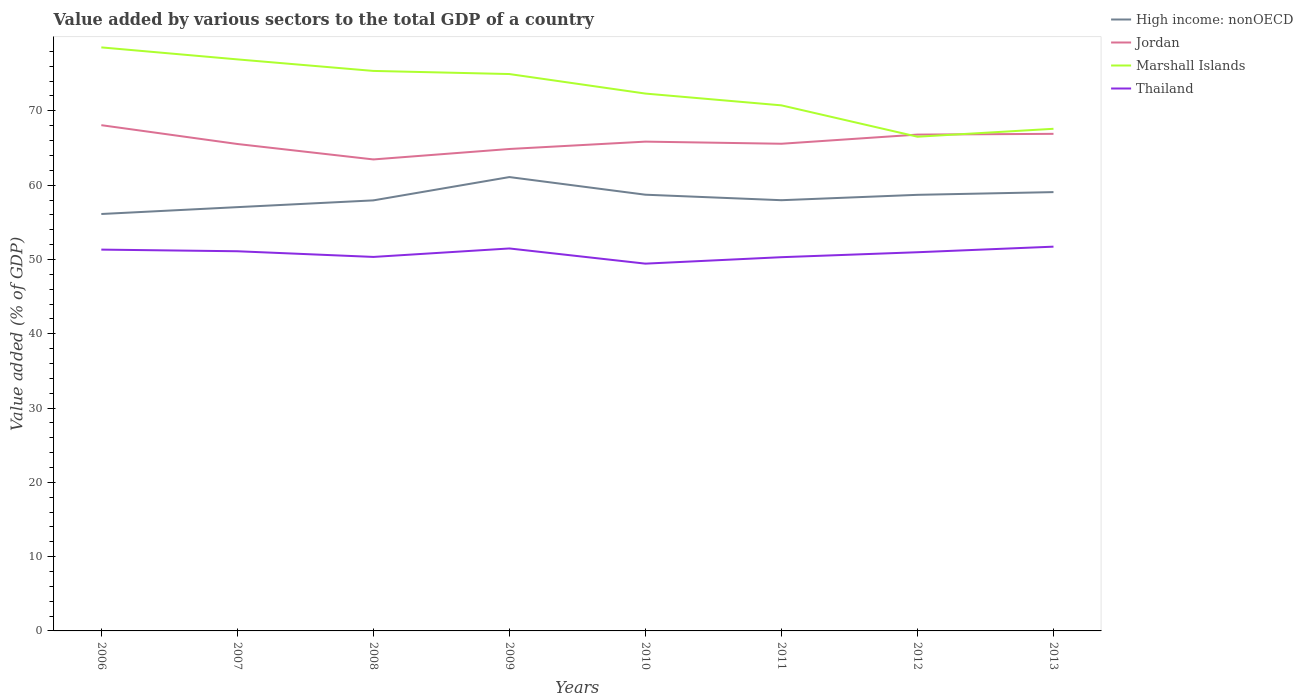Across all years, what is the maximum value added by various sectors to the total GDP in High income: nonOECD?
Ensure brevity in your answer.  56.12. In which year was the value added by various sectors to the total GDP in Thailand maximum?
Offer a terse response. 2010. What is the total value added by various sectors to the total GDP in High income: nonOECD in the graph?
Offer a very short reply. 0.74. What is the difference between the highest and the second highest value added by various sectors to the total GDP in High income: nonOECD?
Make the answer very short. 4.97. What is the difference between the highest and the lowest value added by various sectors to the total GDP in Jordan?
Your answer should be very brief. 3. Is the value added by various sectors to the total GDP in Thailand strictly greater than the value added by various sectors to the total GDP in Marshall Islands over the years?
Your answer should be compact. Yes. How many lines are there?
Your answer should be very brief. 4. How many years are there in the graph?
Provide a short and direct response. 8. What is the difference between two consecutive major ticks on the Y-axis?
Your answer should be compact. 10. Are the values on the major ticks of Y-axis written in scientific E-notation?
Keep it short and to the point. No. Does the graph contain grids?
Your response must be concise. No. Where does the legend appear in the graph?
Make the answer very short. Top right. What is the title of the graph?
Keep it short and to the point. Value added by various sectors to the total GDP of a country. What is the label or title of the Y-axis?
Your response must be concise. Value added (% of GDP). What is the Value added (% of GDP) in High income: nonOECD in 2006?
Your answer should be compact. 56.12. What is the Value added (% of GDP) in Jordan in 2006?
Your answer should be very brief. 68.07. What is the Value added (% of GDP) in Marshall Islands in 2006?
Give a very brief answer. 78.54. What is the Value added (% of GDP) of Thailand in 2006?
Give a very brief answer. 51.32. What is the Value added (% of GDP) of High income: nonOECD in 2007?
Offer a terse response. 57.04. What is the Value added (% of GDP) in Jordan in 2007?
Your answer should be compact. 65.54. What is the Value added (% of GDP) of Marshall Islands in 2007?
Your answer should be very brief. 76.93. What is the Value added (% of GDP) in Thailand in 2007?
Ensure brevity in your answer.  51.1. What is the Value added (% of GDP) of High income: nonOECD in 2008?
Your answer should be very brief. 57.95. What is the Value added (% of GDP) of Jordan in 2008?
Offer a terse response. 63.46. What is the Value added (% of GDP) in Marshall Islands in 2008?
Your response must be concise. 75.37. What is the Value added (% of GDP) in Thailand in 2008?
Your answer should be very brief. 50.34. What is the Value added (% of GDP) in High income: nonOECD in 2009?
Give a very brief answer. 61.09. What is the Value added (% of GDP) of Jordan in 2009?
Provide a short and direct response. 64.87. What is the Value added (% of GDP) of Marshall Islands in 2009?
Your answer should be compact. 74.95. What is the Value added (% of GDP) of Thailand in 2009?
Provide a succinct answer. 51.48. What is the Value added (% of GDP) in High income: nonOECD in 2010?
Make the answer very short. 58.71. What is the Value added (% of GDP) of Jordan in 2010?
Offer a very short reply. 65.86. What is the Value added (% of GDP) of Marshall Islands in 2010?
Your answer should be very brief. 72.33. What is the Value added (% of GDP) in Thailand in 2010?
Provide a succinct answer. 49.44. What is the Value added (% of GDP) in High income: nonOECD in 2011?
Keep it short and to the point. 57.98. What is the Value added (% of GDP) of Jordan in 2011?
Give a very brief answer. 65.57. What is the Value added (% of GDP) in Marshall Islands in 2011?
Provide a short and direct response. 70.74. What is the Value added (% of GDP) of Thailand in 2011?
Your response must be concise. 50.3. What is the Value added (% of GDP) of High income: nonOECD in 2012?
Provide a succinct answer. 58.7. What is the Value added (% of GDP) in Jordan in 2012?
Your answer should be compact. 66.81. What is the Value added (% of GDP) of Marshall Islands in 2012?
Make the answer very short. 66.52. What is the Value added (% of GDP) in Thailand in 2012?
Your answer should be compact. 50.97. What is the Value added (% of GDP) in High income: nonOECD in 2013?
Give a very brief answer. 59.06. What is the Value added (% of GDP) in Jordan in 2013?
Your answer should be very brief. 66.91. What is the Value added (% of GDP) of Marshall Islands in 2013?
Offer a terse response. 67.59. What is the Value added (% of GDP) of Thailand in 2013?
Your response must be concise. 51.72. Across all years, what is the maximum Value added (% of GDP) in High income: nonOECD?
Provide a succinct answer. 61.09. Across all years, what is the maximum Value added (% of GDP) of Jordan?
Provide a succinct answer. 68.07. Across all years, what is the maximum Value added (% of GDP) in Marshall Islands?
Give a very brief answer. 78.54. Across all years, what is the maximum Value added (% of GDP) of Thailand?
Your answer should be compact. 51.72. Across all years, what is the minimum Value added (% of GDP) of High income: nonOECD?
Your answer should be very brief. 56.12. Across all years, what is the minimum Value added (% of GDP) of Jordan?
Your answer should be very brief. 63.46. Across all years, what is the minimum Value added (% of GDP) in Marshall Islands?
Provide a succinct answer. 66.52. Across all years, what is the minimum Value added (% of GDP) of Thailand?
Keep it short and to the point. 49.44. What is the total Value added (% of GDP) in High income: nonOECD in the graph?
Your answer should be compact. 466.65. What is the total Value added (% of GDP) of Jordan in the graph?
Give a very brief answer. 527.09. What is the total Value added (% of GDP) in Marshall Islands in the graph?
Provide a succinct answer. 582.97. What is the total Value added (% of GDP) of Thailand in the graph?
Keep it short and to the point. 406.68. What is the difference between the Value added (% of GDP) in High income: nonOECD in 2006 and that in 2007?
Give a very brief answer. -0.92. What is the difference between the Value added (% of GDP) in Jordan in 2006 and that in 2007?
Provide a short and direct response. 2.53. What is the difference between the Value added (% of GDP) in Marshall Islands in 2006 and that in 2007?
Provide a short and direct response. 1.61. What is the difference between the Value added (% of GDP) in Thailand in 2006 and that in 2007?
Offer a terse response. 0.22. What is the difference between the Value added (% of GDP) in High income: nonOECD in 2006 and that in 2008?
Offer a very short reply. -1.83. What is the difference between the Value added (% of GDP) of Jordan in 2006 and that in 2008?
Your response must be concise. 4.61. What is the difference between the Value added (% of GDP) in Marshall Islands in 2006 and that in 2008?
Provide a short and direct response. 3.17. What is the difference between the Value added (% of GDP) of Thailand in 2006 and that in 2008?
Your answer should be compact. 0.98. What is the difference between the Value added (% of GDP) in High income: nonOECD in 2006 and that in 2009?
Your response must be concise. -4.97. What is the difference between the Value added (% of GDP) of Jordan in 2006 and that in 2009?
Provide a short and direct response. 3.21. What is the difference between the Value added (% of GDP) of Marshall Islands in 2006 and that in 2009?
Your response must be concise. 3.59. What is the difference between the Value added (% of GDP) of Thailand in 2006 and that in 2009?
Offer a terse response. -0.15. What is the difference between the Value added (% of GDP) in High income: nonOECD in 2006 and that in 2010?
Your response must be concise. -2.6. What is the difference between the Value added (% of GDP) of Jordan in 2006 and that in 2010?
Keep it short and to the point. 2.21. What is the difference between the Value added (% of GDP) of Marshall Islands in 2006 and that in 2010?
Ensure brevity in your answer.  6.22. What is the difference between the Value added (% of GDP) in Thailand in 2006 and that in 2010?
Provide a succinct answer. 1.89. What is the difference between the Value added (% of GDP) of High income: nonOECD in 2006 and that in 2011?
Your answer should be very brief. -1.86. What is the difference between the Value added (% of GDP) in Jordan in 2006 and that in 2011?
Offer a terse response. 2.5. What is the difference between the Value added (% of GDP) in Marshall Islands in 2006 and that in 2011?
Give a very brief answer. 7.8. What is the difference between the Value added (% of GDP) in Thailand in 2006 and that in 2011?
Provide a short and direct response. 1.02. What is the difference between the Value added (% of GDP) in High income: nonOECD in 2006 and that in 2012?
Offer a very short reply. -2.58. What is the difference between the Value added (% of GDP) of Jordan in 2006 and that in 2012?
Ensure brevity in your answer.  1.27. What is the difference between the Value added (% of GDP) in Marshall Islands in 2006 and that in 2012?
Offer a terse response. 12.02. What is the difference between the Value added (% of GDP) of Thailand in 2006 and that in 2012?
Ensure brevity in your answer.  0.35. What is the difference between the Value added (% of GDP) of High income: nonOECD in 2006 and that in 2013?
Provide a succinct answer. -2.95. What is the difference between the Value added (% of GDP) in Jordan in 2006 and that in 2013?
Make the answer very short. 1.17. What is the difference between the Value added (% of GDP) of Marshall Islands in 2006 and that in 2013?
Provide a short and direct response. 10.96. What is the difference between the Value added (% of GDP) in Thailand in 2006 and that in 2013?
Offer a terse response. -0.4. What is the difference between the Value added (% of GDP) in High income: nonOECD in 2007 and that in 2008?
Your answer should be compact. -0.91. What is the difference between the Value added (% of GDP) of Jordan in 2007 and that in 2008?
Ensure brevity in your answer.  2.08. What is the difference between the Value added (% of GDP) in Marshall Islands in 2007 and that in 2008?
Your response must be concise. 1.55. What is the difference between the Value added (% of GDP) of Thailand in 2007 and that in 2008?
Give a very brief answer. 0.76. What is the difference between the Value added (% of GDP) of High income: nonOECD in 2007 and that in 2009?
Keep it short and to the point. -4.05. What is the difference between the Value added (% of GDP) of Jordan in 2007 and that in 2009?
Your response must be concise. 0.67. What is the difference between the Value added (% of GDP) of Marshall Islands in 2007 and that in 2009?
Provide a short and direct response. 1.97. What is the difference between the Value added (% of GDP) in Thailand in 2007 and that in 2009?
Your answer should be very brief. -0.38. What is the difference between the Value added (% of GDP) of High income: nonOECD in 2007 and that in 2010?
Offer a very short reply. -1.67. What is the difference between the Value added (% of GDP) of Jordan in 2007 and that in 2010?
Give a very brief answer. -0.32. What is the difference between the Value added (% of GDP) of Marshall Islands in 2007 and that in 2010?
Your answer should be compact. 4.6. What is the difference between the Value added (% of GDP) of Thailand in 2007 and that in 2010?
Your answer should be compact. 1.67. What is the difference between the Value added (% of GDP) of High income: nonOECD in 2007 and that in 2011?
Give a very brief answer. -0.94. What is the difference between the Value added (% of GDP) of Jordan in 2007 and that in 2011?
Offer a very short reply. -0.03. What is the difference between the Value added (% of GDP) in Marshall Islands in 2007 and that in 2011?
Give a very brief answer. 6.19. What is the difference between the Value added (% of GDP) of Thailand in 2007 and that in 2011?
Ensure brevity in your answer.  0.8. What is the difference between the Value added (% of GDP) in High income: nonOECD in 2007 and that in 2012?
Provide a succinct answer. -1.66. What is the difference between the Value added (% of GDP) in Jordan in 2007 and that in 2012?
Offer a terse response. -1.26. What is the difference between the Value added (% of GDP) in Marshall Islands in 2007 and that in 2012?
Your answer should be compact. 10.41. What is the difference between the Value added (% of GDP) in Thailand in 2007 and that in 2012?
Your response must be concise. 0.13. What is the difference between the Value added (% of GDP) in High income: nonOECD in 2007 and that in 2013?
Your response must be concise. -2.02. What is the difference between the Value added (% of GDP) of Jordan in 2007 and that in 2013?
Provide a short and direct response. -1.37. What is the difference between the Value added (% of GDP) of Marshall Islands in 2007 and that in 2013?
Offer a terse response. 9.34. What is the difference between the Value added (% of GDP) of Thailand in 2007 and that in 2013?
Ensure brevity in your answer.  -0.62. What is the difference between the Value added (% of GDP) in High income: nonOECD in 2008 and that in 2009?
Provide a short and direct response. -3.14. What is the difference between the Value added (% of GDP) in Jordan in 2008 and that in 2009?
Ensure brevity in your answer.  -1.41. What is the difference between the Value added (% of GDP) of Marshall Islands in 2008 and that in 2009?
Offer a terse response. 0.42. What is the difference between the Value added (% of GDP) in Thailand in 2008 and that in 2009?
Your answer should be very brief. -1.14. What is the difference between the Value added (% of GDP) in High income: nonOECD in 2008 and that in 2010?
Provide a short and direct response. -0.76. What is the difference between the Value added (% of GDP) in Jordan in 2008 and that in 2010?
Offer a very short reply. -2.4. What is the difference between the Value added (% of GDP) of Marshall Islands in 2008 and that in 2010?
Your answer should be very brief. 3.05. What is the difference between the Value added (% of GDP) in Thailand in 2008 and that in 2010?
Keep it short and to the point. 0.9. What is the difference between the Value added (% of GDP) in High income: nonOECD in 2008 and that in 2011?
Keep it short and to the point. -0.02. What is the difference between the Value added (% of GDP) of Jordan in 2008 and that in 2011?
Provide a short and direct response. -2.11. What is the difference between the Value added (% of GDP) in Marshall Islands in 2008 and that in 2011?
Your answer should be compact. 4.63. What is the difference between the Value added (% of GDP) in Thailand in 2008 and that in 2011?
Provide a short and direct response. 0.03. What is the difference between the Value added (% of GDP) of High income: nonOECD in 2008 and that in 2012?
Give a very brief answer. -0.75. What is the difference between the Value added (% of GDP) of Jordan in 2008 and that in 2012?
Your response must be concise. -3.34. What is the difference between the Value added (% of GDP) of Marshall Islands in 2008 and that in 2012?
Your answer should be compact. 8.86. What is the difference between the Value added (% of GDP) in Thailand in 2008 and that in 2012?
Provide a succinct answer. -0.63. What is the difference between the Value added (% of GDP) in High income: nonOECD in 2008 and that in 2013?
Your response must be concise. -1.11. What is the difference between the Value added (% of GDP) of Jordan in 2008 and that in 2013?
Provide a short and direct response. -3.44. What is the difference between the Value added (% of GDP) in Marshall Islands in 2008 and that in 2013?
Your response must be concise. 7.79. What is the difference between the Value added (% of GDP) of Thailand in 2008 and that in 2013?
Your response must be concise. -1.38. What is the difference between the Value added (% of GDP) of High income: nonOECD in 2009 and that in 2010?
Your answer should be very brief. 2.37. What is the difference between the Value added (% of GDP) in Jordan in 2009 and that in 2010?
Offer a very short reply. -0.99. What is the difference between the Value added (% of GDP) of Marshall Islands in 2009 and that in 2010?
Give a very brief answer. 2.63. What is the difference between the Value added (% of GDP) of Thailand in 2009 and that in 2010?
Provide a short and direct response. 2.04. What is the difference between the Value added (% of GDP) in High income: nonOECD in 2009 and that in 2011?
Provide a succinct answer. 3.11. What is the difference between the Value added (% of GDP) in Jordan in 2009 and that in 2011?
Make the answer very short. -0.71. What is the difference between the Value added (% of GDP) in Marshall Islands in 2009 and that in 2011?
Offer a terse response. 4.21. What is the difference between the Value added (% of GDP) of Thailand in 2009 and that in 2011?
Provide a short and direct response. 1.17. What is the difference between the Value added (% of GDP) of High income: nonOECD in 2009 and that in 2012?
Keep it short and to the point. 2.39. What is the difference between the Value added (% of GDP) of Jordan in 2009 and that in 2012?
Your answer should be very brief. -1.94. What is the difference between the Value added (% of GDP) in Marshall Islands in 2009 and that in 2012?
Provide a succinct answer. 8.43. What is the difference between the Value added (% of GDP) of Thailand in 2009 and that in 2012?
Provide a short and direct response. 0.51. What is the difference between the Value added (% of GDP) of High income: nonOECD in 2009 and that in 2013?
Give a very brief answer. 2.02. What is the difference between the Value added (% of GDP) in Jordan in 2009 and that in 2013?
Make the answer very short. -2.04. What is the difference between the Value added (% of GDP) of Marshall Islands in 2009 and that in 2013?
Ensure brevity in your answer.  7.37. What is the difference between the Value added (% of GDP) of Thailand in 2009 and that in 2013?
Your answer should be very brief. -0.24. What is the difference between the Value added (% of GDP) of High income: nonOECD in 2010 and that in 2011?
Your answer should be very brief. 0.74. What is the difference between the Value added (% of GDP) of Jordan in 2010 and that in 2011?
Offer a terse response. 0.29. What is the difference between the Value added (% of GDP) of Marshall Islands in 2010 and that in 2011?
Your answer should be compact. 1.59. What is the difference between the Value added (% of GDP) of Thailand in 2010 and that in 2011?
Make the answer very short. -0.87. What is the difference between the Value added (% of GDP) of High income: nonOECD in 2010 and that in 2012?
Your answer should be compact. 0.02. What is the difference between the Value added (% of GDP) in Jordan in 2010 and that in 2012?
Give a very brief answer. -0.95. What is the difference between the Value added (% of GDP) in Marshall Islands in 2010 and that in 2012?
Offer a terse response. 5.81. What is the difference between the Value added (% of GDP) of Thailand in 2010 and that in 2012?
Your answer should be compact. -1.53. What is the difference between the Value added (% of GDP) of High income: nonOECD in 2010 and that in 2013?
Offer a terse response. -0.35. What is the difference between the Value added (% of GDP) of Jordan in 2010 and that in 2013?
Offer a very short reply. -1.05. What is the difference between the Value added (% of GDP) in Marshall Islands in 2010 and that in 2013?
Keep it short and to the point. 4.74. What is the difference between the Value added (% of GDP) in Thailand in 2010 and that in 2013?
Give a very brief answer. -2.29. What is the difference between the Value added (% of GDP) of High income: nonOECD in 2011 and that in 2012?
Make the answer very short. -0.72. What is the difference between the Value added (% of GDP) of Jordan in 2011 and that in 2012?
Give a very brief answer. -1.23. What is the difference between the Value added (% of GDP) in Marshall Islands in 2011 and that in 2012?
Offer a terse response. 4.22. What is the difference between the Value added (% of GDP) in Thailand in 2011 and that in 2012?
Offer a terse response. -0.67. What is the difference between the Value added (% of GDP) of High income: nonOECD in 2011 and that in 2013?
Your answer should be compact. -1.09. What is the difference between the Value added (% of GDP) of Jordan in 2011 and that in 2013?
Provide a short and direct response. -1.33. What is the difference between the Value added (% of GDP) of Marshall Islands in 2011 and that in 2013?
Your response must be concise. 3.15. What is the difference between the Value added (% of GDP) of Thailand in 2011 and that in 2013?
Offer a terse response. -1.42. What is the difference between the Value added (% of GDP) of High income: nonOECD in 2012 and that in 2013?
Offer a very short reply. -0.37. What is the difference between the Value added (% of GDP) in Jordan in 2012 and that in 2013?
Make the answer very short. -0.1. What is the difference between the Value added (% of GDP) of Marshall Islands in 2012 and that in 2013?
Provide a succinct answer. -1.07. What is the difference between the Value added (% of GDP) in Thailand in 2012 and that in 2013?
Offer a terse response. -0.75. What is the difference between the Value added (% of GDP) of High income: nonOECD in 2006 and the Value added (% of GDP) of Jordan in 2007?
Your response must be concise. -9.42. What is the difference between the Value added (% of GDP) of High income: nonOECD in 2006 and the Value added (% of GDP) of Marshall Islands in 2007?
Make the answer very short. -20.81. What is the difference between the Value added (% of GDP) in High income: nonOECD in 2006 and the Value added (% of GDP) in Thailand in 2007?
Your response must be concise. 5.01. What is the difference between the Value added (% of GDP) of Jordan in 2006 and the Value added (% of GDP) of Marshall Islands in 2007?
Give a very brief answer. -8.85. What is the difference between the Value added (% of GDP) in Jordan in 2006 and the Value added (% of GDP) in Thailand in 2007?
Offer a very short reply. 16.97. What is the difference between the Value added (% of GDP) of Marshall Islands in 2006 and the Value added (% of GDP) of Thailand in 2007?
Make the answer very short. 27.44. What is the difference between the Value added (% of GDP) in High income: nonOECD in 2006 and the Value added (% of GDP) in Jordan in 2008?
Keep it short and to the point. -7.34. What is the difference between the Value added (% of GDP) in High income: nonOECD in 2006 and the Value added (% of GDP) in Marshall Islands in 2008?
Offer a terse response. -19.26. What is the difference between the Value added (% of GDP) of High income: nonOECD in 2006 and the Value added (% of GDP) of Thailand in 2008?
Give a very brief answer. 5.78. What is the difference between the Value added (% of GDP) in Jordan in 2006 and the Value added (% of GDP) in Marshall Islands in 2008?
Offer a terse response. -7.3. What is the difference between the Value added (% of GDP) in Jordan in 2006 and the Value added (% of GDP) in Thailand in 2008?
Your answer should be compact. 17.73. What is the difference between the Value added (% of GDP) in Marshall Islands in 2006 and the Value added (% of GDP) in Thailand in 2008?
Give a very brief answer. 28.2. What is the difference between the Value added (% of GDP) of High income: nonOECD in 2006 and the Value added (% of GDP) of Jordan in 2009?
Ensure brevity in your answer.  -8.75. What is the difference between the Value added (% of GDP) of High income: nonOECD in 2006 and the Value added (% of GDP) of Marshall Islands in 2009?
Your answer should be very brief. -18.84. What is the difference between the Value added (% of GDP) in High income: nonOECD in 2006 and the Value added (% of GDP) in Thailand in 2009?
Provide a short and direct response. 4.64. What is the difference between the Value added (% of GDP) in Jordan in 2006 and the Value added (% of GDP) in Marshall Islands in 2009?
Your answer should be compact. -6.88. What is the difference between the Value added (% of GDP) of Jordan in 2006 and the Value added (% of GDP) of Thailand in 2009?
Provide a short and direct response. 16.59. What is the difference between the Value added (% of GDP) of Marshall Islands in 2006 and the Value added (% of GDP) of Thailand in 2009?
Ensure brevity in your answer.  27.06. What is the difference between the Value added (% of GDP) in High income: nonOECD in 2006 and the Value added (% of GDP) in Jordan in 2010?
Your response must be concise. -9.74. What is the difference between the Value added (% of GDP) in High income: nonOECD in 2006 and the Value added (% of GDP) in Marshall Islands in 2010?
Your response must be concise. -16.21. What is the difference between the Value added (% of GDP) in High income: nonOECD in 2006 and the Value added (% of GDP) in Thailand in 2010?
Provide a short and direct response. 6.68. What is the difference between the Value added (% of GDP) in Jordan in 2006 and the Value added (% of GDP) in Marshall Islands in 2010?
Keep it short and to the point. -4.25. What is the difference between the Value added (% of GDP) in Jordan in 2006 and the Value added (% of GDP) in Thailand in 2010?
Ensure brevity in your answer.  18.64. What is the difference between the Value added (% of GDP) in Marshall Islands in 2006 and the Value added (% of GDP) in Thailand in 2010?
Make the answer very short. 29.11. What is the difference between the Value added (% of GDP) in High income: nonOECD in 2006 and the Value added (% of GDP) in Jordan in 2011?
Provide a succinct answer. -9.46. What is the difference between the Value added (% of GDP) in High income: nonOECD in 2006 and the Value added (% of GDP) in Marshall Islands in 2011?
Give a very brief answer. -14.62. What is the difference between the Value added (% of GDP) in High income: nonOECD in 2006 and the Value added (% of GDP) in Thailand in 2011?
Your answer should be compact. 5.81. What is the difference between the Value added (% of GDP) of Jordan in 2006 and the Value added (% of GDP) of Marshall Islands in 2011?
Make the answer very short. -2.67. What is the difference between the Value added (% of GDP) of Jordan in 2006 and the Value added (% of GDP) of Thailand in 2011?
Keep it short and to the point. 17.77. What is the difference between the Value added (% of GDP) in Marshall Islands in 2006 and the Value added (% of GDP) in Thailand in 2011?
Your answer should be compact. 28.24. What is the difference between the Value added (% of GDP) in High income: nonOECD in 2006 and the Value added (% of GDP) in Jordan in 2012?
Your response must be concise. -10.69. What is the difference between the Value added (% of GDP) in High income: nonOECD in 2006 and the Value added (% of GDP) in Marshall Islands in 2012?
Provide a short and direct response. -10.4. What is the difference between the Value added (% of GDP) in High income: nonOECD in 2006 and the Value added (% of GDP) in Thailand in 2012?
Ensure brevity in your answer.  5.15. What is the difference between the Value added (% of GDP) of Jordan in 2006 and the Value added (% of GDP) of Marshall Islands in 2012?
Keep it short and to the point. 1.55. What is the difference between the Value added (% of GDP) in Jordan in 2006 and the Value added (% of GDP) in Thailand in 2012?
Offer a terse response. 17.1. What is the difference between the Value added (% of GDP) in Marshall Islands in 2006 and the Value added (% of GDP) in Thailand in 2012?
Keep it short and to the point. 27.57. What is the difference between the Value added (% of GDP) in High income: nonOECD in 2006 and the Value added (% of GDP) in Jordan in 2013?
Offer a very short reply. -10.79. What is the difference between the Value added (% of GDP) in High income: nonOECD in 2006 and the Value added (% of GDP) in Marshall Islands in 2013?
Offer a terse response. -11.47. What is the difference between the Value added (% of GDP) of High income: nonOECD in 2006 and the Value added (% of GDP) of Thailand in 2013?
Keep it short and to the point. 4.4. What is the difference between the Value added (% of GDP) in Jordan in 2006 and the Value added (% of GDP) in Marshall Islands in 2013?
Make the answer very short. 0.49. What is the difference between the Value added (% of GDP) of Jordan in 2006 and the Value added (% of GDP) of Thailand in 2013?
Provide a short and direct response. 16.35. What is the difference between the Value added (% of GDP) of Marshall Islands in 2006 and the Value added (% of GDP) of Thailand in 2013?
Your answer should be very brief. 26.82. What is the difference between the Value added (% of GDP) of High income: nonOECD in 2007 and the Value added (% of GDP) of Jordan in 2008?
Provide a short and direct response. -6.42. What is the difference between the Value added (% of GDP) in High income: nonOECD in 2007 and the Value added (% of GDP) in Marshall Islands in 2008?
Offer a very short reply. -18.33. What is the difference between the Value added (% of GDP) of High income: nonOECD in 2007 and the Value added (% of GDP) of Thailand in 2008?
Your response must be concise. 6.7. What is the difference between the Value added (% of GDP) of Jordan in 2007 and the Value added (% of GDP) of Marshall Islands in 2008?
Your answer should be compact. -9.83. What is the difference between the Value added (% of GDP) of Jordan in 2007 and the Value added (% of GDP) of Thailand in 2008?
Your answer should be very brief. 15.2. What is the difference between the Value added (% of GDP) in Marshall Islands in 2007 and the Value added (% of GDP) in Thailand in 2008?
Provide a succinct answer. 26.59. What is the difference between the Value added (% of GDP) in High income: nonOECD in 2007 and the Value added (% of GDP) in Jordan in 2009?
Make the answer very short. -7.83. What is the difference between the Value added (% of GDP) in High income: nonOECD in 2007 and the Value added (% of GDP) in Marshall Islands in 2009?
Keep it short and to the point. -17.91. What is the difference between the Value added (% of GDP) of High income: nonOECD in 2007 and the Value added (% of GDP) of Thailand in 2009?
Your response must be concise. 5.56. What is the difference between the Value added (% of GDP) of Jordan in 2007 and the Value added (% of GDP) of Marshall Islands in 2009?
Keep it short and to the point. -9.41. What is the difference between the Value added (% of GDP) of Jordan in 2007 and the Value added (% of GDP) of Thailand in 2009?
Offer a terse response. 14.06. What is the difference between the Value added (% of GDP) of Marshall Islands in 2007 and the Value added (% of GDP) of Thailand in 2009?
Ensure brevity in your answer.  25.45. What is the difference between the Value added (% of GDP) of High income: nonOECD in 2007 and the Value added (% of GDP) of Jordan in 2010?
Ensure brevity in your answer.  -8.82. What is the difference between the Value added (% of GDP) in High income: nonOECD in 2007 and the Value added (% of GDP) in Marshall Islands in 2010?
Your response must be concise. -15.29. What is the difference between the Value added (% of GDP) of High income: nonOECD in 2007 and the Value added (% of GDP) of Thailand in 2010?
Provide a short and direct response. 7.6. What is the difference between the Value added (% of GDP) in Jordan in 2007 and the Value added (% of GDP) in Marshall Islands in 2010?
Your response must be concise. -6.79. What is the difference between the Value added (% of GDP) of Jordan in 2007 and the Value added (% of GDP) of Thailand in 2010?
Offer a very short reply. 16.11. What is the difference between the Value added (% of GDP) of Marshall Islands in 2007 and the Value added (% of GDP) of Thailand in 2010?
Your answer should be compact. 27.49. What is the difference between the Value added (% of GDP) of High income: nonOECD in 2007 and the Value added (% of GDP) of Jordan in 2011?
Your response must be concise. -8.53. What is the difference between the Value added (% of GDP) of High income: nonOECD in 2007 and the Value added (% of GDP) of Marshall Islands in 2011?
Offer a very short reply. -13.7. What is the difference between the Value added (% of GDP) of High income: nonOECD in 2007 and the Value added (% of GDP) of Thailand in 2011?
Your response must be concise. 6.74. What is the difference between the Value added (% of GDP) of Jordan in 2007 and the Value added (% of GDP) of Marshall Islands in 2011?
Your answer should be compact. -5.2. What is the difference between the Value added (% of GDP) of Jordan in 2007 and the Value added (% of GDP) of Thailand in 2011?
Your answer should be very brief. 15.24. What is the difference between the Value added (% of GDP) of Marshall Islands in 2007 and the Value added (% of GDP) of Thailand in 2011?
Offer a very short reply. 26.62. What is the difference between the Value added (% of GDP) of High income: nonOECD in 2007 and the Value added (% of GDP) of Jordan in 2012?
Provide a succinct answer. -9.77. What is the difference between the Value added (% of GDP) in High income: nonOECD in 2007 and the Value added (% of GDP) in Marshall Islands in 2012?
Provide a succinct answer. -9.48. What is the difference between the Value added (% of GDP) in High income: nonOECD in 2007 and the Value added (% of GDP) in Thailand in 2012?
Your answer should be compact. 6.07. What is the difference between the Value added (% of GDP) in Jordan in 2007 and the Value added (% of GDP) in Marshall Islands in 2012?
Provide a succinct answer. -0.98. What is the difference between the Value added (% of GDP) of Jordan in 2007 and the Value added (% of GDP) of Thailand in 2012?
Provide a short and direct response. 14.57. What is the difference between the Value added (% of GDP) of Marshall Islands in 2007 and the Value added (% of GDP) of Thailand in 2012?
Provide a succinct answer. 25.96. What is the difference between the Value added (% of GDP) of High income: nonOECD in 2007 and the Value added (% of GDP) of Jordan in 2013?
Provide a succinct answer. -9.87. What is the difference between the Value added (% of GDP) of High income: nonOECD in 2007 and the Value added (% of GDP) of Marshall Islands in 2013?
Give a very brief answer. -10.55. What is the difference between the Value added (% of GDP) in High income: nonOECD in 2007 and the Value added (% of GDP) in Thailand in 2013?
Your answer should be compact. 5.32. What is the difference between the Value added (% of GDP) in Jordan in 2007 and the Value added (% of GDP) in Marshall Islands in 2013?
Make the answer very short. -2.05. What is the difference between the Value added (% of GDP) of Jordan in 2007 and the Value added (% of GDP) of Thailand in 2013?
Keep it short and to the point. 13.82. What is the difference between the Value added (% of GDP) in Marshall Islands in 2007 and the Value added (% of GDP) in Thailand in 2013?
Offer a very short reply. 25.21. What is the difference between the Value added (% of GDP) of High income: nonOECD in 2008 and the Value added (% of GDP) of Jordan in 2009?
Provide a short and direct response. -6.92. What is the difference between the Value added (% of GDP) of High income: nonOECD in 2008 and the Value added (% of GDP) of Marshall Islands in 2009?
Keep it short and to the point. -17. What is the difference between the Value added (% of GDP) of High income: nonOECD in 2008 and the Value added (% of GDP) of Thailand in 2009?
Your answer should be very brief. 6.47. What is the difference between the Value added (% of GDP) in Jordan in 2008 and the Value added (% of GDP) in Marshall Islands in 2009?
Your answer should be very brief. -11.49. What is the difference between the Value added (% of GDP) of Jordan in 2008 and the Value added (% of GDP) of Thailand in 2009?
Keep it short and to the point. 11.98. What is the difference between the Value added (% of GDP) in Marshall Islands in 2008 and the Value added (% of GDP) in Thailand in 2009?
Keep it short and to the point. 23.9. What is the difference between the Value added (% of GDP) in High income: nonOECD in 2008 and the Value added (% of GDP) in Jordan in 2010?
Give a very brief answer. -7.91. What is the difference between the Value added (% of GDP) of High income: nonOECD in 2008 and the Value added (% of GDP) of Marshall Islands in 2010?
Your answer should be very brief. -14.38. What is the difference between the Value added (% of GDP) in High income: nonOECD in 2008 and the Value added (% of GDP) in Thailand in 2010?
Your answer should be compact. 8.52. What is the difference between the Value added (% of GDP) in Jordan in 2008 and the Value added (% of GDP) in Marshall Islands in 2010?
Give a very brief answer. -8.87. What is the difference between the Value added (% of GDP) of Jordan in 2008 and the Value added (% of GDP) of Thailand in 2010?
Ensure brevity in your answer.  14.03. What is the difference between the Value added (% of GDP) of Marshall Islands in 2008 and the Value added (% of GDP) of Thailand in 2010?
Offer a terse response. 25.94. What is the difference between the Value added (% of GDP) of High income: nonOECD in 2008 and the Value added (% of GDP) of Jordan in 2011?
Offer a terse response. -7.62. What is the difference between the Value added (% of GDP) in High income: nonOECD in 2008 and the Value added (% of GDP) in Marshall Islands in 2011?
Provide a short and direct response. -12.79. What is the difference between the Value added (% of GDP) of High income: nonOECD in 2008 and the Value added (% of GDP) of Thailand in 2011?
Your answer should be compact. 7.65. What is the difference between the Value added (% of GDP) in Jordan in 2008 and the Value added (% of GDP) in Marshall Islands in 2011?
Your answer should be very brief. -7.28. What is the difference between the Value added (% of GDP) in Jordan in 2008 and the Value added (% of GDP) in Thailand in 2011?
Give a very brief answer. 13.16. What is the difference between the Value added (% of GDP) in Marshall Islands in 2008 and the Value added (% of GDP) in Thailand in 2011?
Make the answer very short. 25.07. What is the difference between the Value added (% of GDP) in High income: nonOECD in 2008 and the Value added (% of GDP) in Jordan in 2012?
Give a very brief answer. -8.85. What is the difference between the Value added (% of GDP) in High income: nonOECD in 2008 and the Value added (% of GDP) in Marshall Islands in 2012?
Provide a succinct answer. -8.57. What is the difference between the Value added (% of GDP) of High income: nonOECD in 2008 and the Value added (% of GDP) of Thailand in 2012?
Keep it short and to the point. 6.98. What is the difference between the Value added (% of GDP) of Jordan in 2008 and the Value added (% of GDP) of Marshall Islands in 2012?
Offer a terse response. -3.06. What is the difference between the Value added (% of GDP) of Jordan in 2008 and the Value added (% of GDP) of Thailand in 2012?
Your response must be concise. 12.49. What is the difference between the Value added (% of GDP) of Marshall Islands in 2008 and the Value added (% of GDP) of Thailand in 2012?
Ensure brevity in your answer.  24.4. What is the difference between the Value added (% of GDP) in High income: nonOECD in 2008 and the Value added (% of GDP) in Jordan in 2013?
Your answer should be very brief. -8.96. What is the difference between the Value added (% of GDP) in High income: nonOECD in 2008 and the Value added (% of GDP) in Marshall Islands in 2013?
Offer a very short reply. -9.64. What is the difference between the Value added (% of GDP) in High income: nonOECD in 2008 and the Value added (% of GDP) in Thailand in 2013?
Keep it short and to the point. 6.23. What is the difference between the Value added (% of GDP) in Jordan in 2008 and the Value added (% of GDP) in Marshall Islands in 2013?
Your answer should be compact. -4.12. What is the difference between the Value added (% of GDP) of Jordan in 2008 and the Value added (% of GDP) of Thailand in 2013?
Provide a succinct answer. 11.74. What is the difference between the Value added (% of GDP) of Marshall Islands in 2008 and the Value added (% of GDP) of Thailand in 2013?
Make the answer very short. 23.65. What is the difference between the Value added (% of GDP) of High income: nonOECD in 2009 and the Value added (% of GDP) of Jordan in 2010?
Give a very brief answer. -4.77. What is the difference between the Value added (% of GDP) of High income: nonOECD in 2009 and the Value added (% of GDP) of Marshall Islands in 2010?
Make the answer very short. -11.24. What is the difference between the Value added (% of GDP) of High income: nonOECD in 2009 and the Value added (% of GDP) of Thailand in 2010?
Your answer should be compact. 11.65. What is the difference between the Value added (% of GDP) in Jordan in 2009 and the Value added (% of GDP) in Marshall Islands in 2010?
Keep it short and to the point. -7.46. What is the difference between the Value added (% of GDP) of Jordan in 2009 and the Value added (% of GDP) of Thailand in 2010?
Ensure brevity in your answer.  15.43. What is the difference between the Value added (% of GDP) in Marshall Islands in 2009 and the Value added (% of GDP) in Thailand in 2010?
Offer a very short reply. 25.52. What is the difference between the Value added (% of GDP) of High income: nonOECD in 2009 and the Value added (% of GDP) of Jordan in 2011?
Provide a short and direct response. -4.49. What is the difference between the Value added (% of GDP) of High income: nonOECD in 2009 and the Value added (% of GDP) of Marshall Islands in 2011?
Your answer should be very brief. -9.65. What is the difference between the Value added (% of GDP) in High income: nonOECD in 2009 and the Value added (% of GDP) in Thailand in 2011?
Ensure brevity in your answer.  10.78. What is the difference between the Value added (% of GDP) in Jordan in 2009 and the Value added (% of GDP) in Marshall Islands in 2011?
Give a very brief answer. -5.87. What is the difference between the Value added (% of GDP) in Jordan in 2009 and the Value added (% of GDP) in Thailand in 2011?
Your response must be concise. 14.56. What is the difference between the Value added (% of GDP) of Marshall Islands in 2009 and the Value added (% of GDP) of Thailand in 2011?
Make the answer very short. 24.65. What is the difference between the Value added (% of GDP) in High income: nonOECD in 2009 and the Value added (% of GDP) in Jordan in 2012?
Provide a short and direct response. -5.72. What is the difference between the Value added (% of GDP) in High income: nonOECD in 2009 and the Value added (% of GDP) in Marshall Islands in 2012?
Offer a terse response. -5.43. What is the difference between the Value added (% of GDP) in High income: nonOECD in 2009 and the Value added (% of GDP) in Thailand in 2012?
Offer a terse response. 10.12. What is the difference between the Value added (% of GDP) of Jordan in 2009 and the Value added (% of GDP) of Marshall Islands in 2012?
Offer a terse response. -1.65. What is the difference between the Value added (% of GDP) in Jordan in 2009 and the Value added (% of GDP) in Thailand in 2012?
Provide a succinct answer. 13.9. What is the difference between the Value added (% of GDP) of Marshall Islands in 2009 and the Value added (% of GDP) of Thailand in 2012?
Ensure brevity in your answer.  23.98. What is the difference between the Value added (% of GDP) in High income: nonOECD in 2009 and the Value added (% of GDP) in Jordan in 2013?
Keep it short and to the point. -5.82. What is the difference between the Value added (% of GDP) in High income: nonOECD in 2009 and the Value added (% of GDP) in Marshall Islands in 2013?
Your response must be concise. -6.5. What is the difference between the Value added (% of GDP) in High income: nonOECD in 2009 and the Value added (% of GDP) in Thailand in 2013?
Keep it short and to the point. 9.37. What is the difference between the Value added (% of GDP) of Jordan in 2009 and the Value added (% of GDP) of Marshall Islands in 2013?
Offer a terse response. -2.72. What is the difference between the Value added (% of GDP) of Jordan in 2009 and the Value added (% of GDP) of Thailand in 2013?
Provide a short and direct response. 13.14. What is the difference between the Value added (% of GDP) of Marshall Islands in 2009 and the Value added (% of GDP) of Thailand in 2013?
Provide a succinct answer. 23.23. What is the difference between the Value added (% of GDP) in High income: nonOECD in 2010 and the Value added (% of GDP) in Jordan in 2011?
Your answer should be compact. -6.86. What is the difference between the Value added (% of GDP) in High income: nonOECD in 2010 and the Value added (% of GDP) in Marshall Islands in 2011?
Give a very brief answer. -12.03. What is the difference between the Value added (% of GDP) in High income: nonOECD in 2010 and the Value added (% of GDP) in Thailand in 2011?
Provide a short and direct response. 8.41. What is the difference between the Value added (% of GDP) in Jordan in 2010 and the Value added (% of GDP) in Marshall Islands in 2011?
Provide a short and direct response. -4.88. What is the difference between the Value added (% of GDP) of Jordan in 2010 and the Value added (% of GDP) of Thailand in 2011?
Offer a terse response. 15.55. What is the difference between the Value added (% of GDP) of Marshall Islands in 2010 and the Value added (% of GDP) of Thailand in 2011?
Ensure brevity in your answer.  22.02. What is the difference between the Value added (% of GDP) in High income: nonOECD in 2010 and the Value added (% of GDP) in Jordan in 2012?
Ensure brevity in your answer.  -8.09. What is the difference between the Value added (% of GDP) of High income: nonOECD in 2010 and the Value added (% of GDP) of Marshall Islands in 2012?
Your answer should be very brief. -7.81. What is the difference between the Value added (% of GDP) of High income: nonOECD in 2010 and the Value added (% of GDP) of Thailand in 2012?
Make the answer very short. 7.74. What is the difference between the Value added (% of GDP) in Jordan in 2010 and the Value added (% of GDP) in Marshall Islands in 2012?
Offer a terse response. -0.66. What is the difference between the Value added (% of GDP) of Jordan in 2010 and the Value added (% of GDP) of Thailand in 2012?
Keep it short and to the point. 14.89. What is the difference between the Value added (% of GDP) in Marshall Islands in 2010 and the Value added (% of GDP) in Thailand in 2012?
Provide a succinct answer. 21.36. What is the difference between the Value added (% of GDP) of High income: nonOECD in 2010 and the Value added (% of GDP) of Jordan in 2013?
Keep it short and to the point. -8.19. What is the difference between the Value added (% of GDP) of High income: nonOECD in 2010 and the Value added (% of GDP) of Marshall Islands in 2013?
Your answer should be compact. -8.87. What is the difference between the Value added (% of GDP) in High income: nonOECD in 2010 and the Value added (% of GDP) in Thailand in 2013?
Give a very brief answer. 6.99. What is the difference between the Value added (% of GDP) of Jordan in 2010 and the Value added (% of GDP) of Marshall Islands in 2013?
Your response must be concise. -1.73. What is the difference between the Value added (% of GDP) in Jordan in 2010 and the Value added (% of GDP) in Thailand in 2013?
Provide a short and direct response. 14.14. What is the difference between the Value added (% of GDP) of Marshall Islands in 2010 and the Value added (% of GDP) of Thailand in 2013?
Ensure brevity in your answer.  20.6. What is the difference between the Value added (% of GDP) in High income: nonOECD in 2011 and the Value added (% of GDP) in Jordan in 2012?
Offer a very short reply. -8.83. What is the difference between the Value added (% of GDP) of High income: nonOECD in 2011 and the Value added (% of GDP) of Marshall Islands in 2012?
Provide a succinct answer. -8.54. What is the difference between the Value added (% of GDP) of High income: nonOECD in 2011 and the Value added (% of GDP) of Thailand in 2012?
Give a very brief answer. 7. What is the difference between the Value added (% of GDP) in Jordan in 2011 and the Value added (% of GDP) in Marshall Islands in 2012?
Keep it short and to the point. -0.95. What is the difference between the Value added (% of GDP) in Jordan in 2011 and the Value added (% of GDP) in Thailand in 2012?
Offer a terse response. 14.6. What is the difference between the Value added (% of GDP) in Marshall Islands in 2011 and the Value added (% of GDP) in Thailand in 2012?
Provide a succinct answer. 19.77. What is the difference between the Value added (% of GDP) in High income: nonOECD in 2011 and the Value added (% of GDP) in Jordan in 2013?
Keep it short and to the point. -8.93. What is the difference between the Value added (% of GDP) in High income: nonOECD in 2011 and the Value added (% of GDP) in Marshall Islands in 2013?
Offer a terse response. -9.61. What is the difference between the Value added (% of GDP) of High income: nonOECD in 2011 and the Value added (% of GDP) of Thailand in 2013?
Offer a terse response. 6.25. What is the difference between the Value added (% of GDP) of Jordan in 2011 and the Value added (% of GDP) of Marshall Islands in 2013?
Offer a very short reply. -2.01. What is the difference between the Value added (% of GDP) in Jordan in 2011 and the Value added (% of GDP) in Thailand in 2013?
Offer a terse response. 13.85. What is the difference between the Value added (% of GDP) of Marshall Islands in 2011 and the Value added (% of GDP) of Thailand in 2013?
Offer a very short reply. 19.02. What is the difference between the Value added (% of GDP) of High income: nonOECD in 2012 and the Value added (% of GDP) of Jordan in 2013?
Your response must be concise. -8.21. What is the difference between the Value added (% of GDP) in High income: nonOECD in 2012 and the Value added (% of GDP) in Marshall Islands in 2013?
Your response must be concise. -8.89. What is the difference between the Value added (% of GDP) of High income: nonOECD in 2012 and the Value added (% of GDP) of Thailand in 2013?
Offer a terse response. 6.98. What is the difference between the Value added (% of GDP) in Jordan in 2012 and the Value added (% of GDP) in Marshall Islands in 2013?
Provide a succinct answer. -0.78. What is the difference between the Value added (% of GDP) in Jordan in 2012 and the Value added (% of GDP) in Thailand in 2013?
Provide a short and direct response. 15.08. What is the difference between the Value added (% of GDP) in Marshall Islands in 2012 and the Value added (% of GDP) in Thailand in 2013?
Keep it short and to the point. 14.8. What is the average Value added (% of GDP) in High income: nonOECD per year?
Your answer should be very brief. 58.33. What is the average Value added (% of GDP) of Jordan per year?
Your answer should be very brief. 65.89. What is the average Value added (% of GDP) of Marshall Islands per year?
Offer a very short reply. 72.87. What is the average Value added (% of GDP) of Thailand per year?
Your answer should be very brief. 50.83. In the year 2006, what is the difference between the Value added (% of GDP) of High income: nonOECD and Value added (% of GDP) of Jordan?
Your answer should be very brief. -11.96. In the year 2006, what is the difference between the Value added (% of GDP) of High income: nonOECD and Value added (% of GDP) of Marshall Islands?
Offer a terse response. -22.43. In the year 2006, what is the difference between the Value added (% of GDP) of High income: nonOECD and Value added (% of GDP) of Thailand?
Offer a very short reply. 4.79. In the year 2006, what is the difference between the Value added (% of GDP) in Jordan and Value added (% of GDP) in Marshall Islands?
Provide a succinct answer. -10.47. In the year 2006, what is the difference between the Value added (% of GDP) in Jordan and Value added (% of GDP) in Thailand?
Offer a terse response. 16.75. In the year 2006, what is the difference between the Value added (% of GDP) in Marshall Islands and Value added (% of GDP) in Thailand?
Keep it short and to the point. 27.22. In the year 2007, what is the difference between the Value added (% of GDP) of High income: nonOECD and Value added (% of GDP) of Jordan?
Make the answer very short. -8.5. In the year 2007, what is the difference between the Value added (% of GDP) of High income: nonOECD and Value added (% of GDP) of Marshall Islands?
Give a very brief answer. -19.89. In the year 2007, what is the difference between the Value added (% of GDP) in High income: nonOECD and Value added (% of GDP) in Thailand?
Provide a succinct answer. 5.94. In the year 2007, what is the difference between the Value added (% of GDP) of Jordan and Value added (% of GDP) of Marshall Islands?
Your answer should be compact. -11.39. In the year 2007, what is the difference between the Value added (% of GDP) of Jordan and Value added (% of GDP) of Thailand?
Your response must be concise. 14.44. In the year 2007, what is the difference between the Value added (% of GDP) in Marshall Islands and Value added (% of GDP) in Thailand?
Ensure brevity in your answer.  25.82. In the year 2008, what is the difference between the Value added (% of GDP) of High income: nonOECD and Value added (% of GDP) of Jordan?
Offer a very short reply. -5.51. In the year 2008, what is the difference between the Value added (% of GDP) of High income: nonOECD and Value added (% of GDP) of Marshall Islands?
Give a very brief answer. -17.42. In the year 2008, what is the difference between the Value added (% of GDP) of High income: nonOECD and Value added (% of GDP) of Thailand?
Your answer should be compact. 7.61. In the year 2008, what is the difference between the Value added (% of GDP) of Jordan and Value added (% of GDP) of Marshall Islands?
Make the answer very short. -11.91. In the year 2008, what is the difference between the Value added (% of GDP) of Jordan and Value added (% of GDP) of Thailand?
Ensure brevity in your answer.  13.12. In the year 2008, what is the difference between the Value added (% of GDP) in Marshall Islands and Value added (% of GDP) in Thailand?
Make the answer very short. 25.04. In the year 2009, what is the difference between the Value added (% of GDP) in High income: nonOECD and Value added (% of GDP) in Jordan?
Keep it short and to the point. -3.78. In the year 2009, what is the difference between the Value added (% of GDP) in High income: nonOECD and Value added (% of GDP) in Marshall Islands?
Give a very brief answer. -13.87. In the year 2009, what is the difference between the Value added (% of GDP) of High income: nonOECD and Value added (% of GDP) of Thailand?
Your answer should be very brief. 9.61. In the year 2009, what is the difference between the Value added (% of GDP) in Jordan and Value added (% of GDP) in Marshall Islands?
Make the answer very short. -10.09. In the year 2009, what is the difference between the Value added (% of GDP) in Jordan and Value added (% of GDP) in Thailand?
Ensure brevity in your answer.  13.39. In the year 2009, what is the difference between the Value added (% of GDP) of Marshall Islands and Value added (% of GDP) of Thailand?
Provide a short and direct response. 23.48. In the year 2010, what is the difference between the Value added (% of GDP) in High income: nonOECD and Value added (% of GDP) in Jordan?
Provide a short and direct response. -7.14. In the year 2010, what is the difference between the Value added (% of GDP) of High income: nonOECD and Value added (% of GDP) of Marshall Islands?
Make the answer very short. -13.61. In the year 2010, what is the difference between the Value added (% of GDP) of High income: nonOECD and Value added (% of GDP) of Thailand?
Your answer should be very brief. 9.28. In the year 2010, what is the difference between the Value added (% of GDP) of Jordan and Value added (% of GDP) of Marshall Islands?
Give a very brief answer. -6.47. In the year 2010, what is the difference between the Value added (% of GDP) in Jordan and Value added (% of GDP) in Thailand?
Ensure brevity in your answer.  16.42. In the year 2010, what is the difference between the Value added (% of GDP) in Marshall Islands and Value added (% of GDP) in Thailand?
Offer a very short reply. 22.89. In the year 2011, what is the difference between the Value added (% of GDP) of High income: nonOECD and Value added (% of GDP) of Jordan?
Provide a short and direct response. -7.6. In the year 2011, what is the difference between the Value added (% of GDP) in High income: nonOECD and Value added (% of GDP) in Marshall Islands?
Your response must be concise. -12.76. In the year 2011, what is the difference between the Value added (% of GDP) of High income: nonOECD and Value added (% of GDP) of Thailand?
Provide a succinct answer. 7.67. In the year 2011, what is the difference between the Value added (% of GDP) of Jordan and Value added (% of GDP) of Marshall Islands?
Keep it short and to the point. -5.17. In the year 2011, what is the difference between the Value added (% of GDP) of Jordan and Value added (% of GDP) of Thailand?
Make the answer very short. 15.27. In the year 2011, what is the difference between the Value added (% of GDP) in Marshall Islands and Value added (% of GDP) in Thailand?
Your answer should be very brief. 20.44. In the year 2012, what is the difference between the Value added (% of GDP) in High income: nonOECD and Value added (% of GDP) in Jordan?
Offer a very short reply. -8.11. In the year 2012, what is the difference between the Value added (% of GDP) of High income: nonOECD and Value added (% of GDP) of Marshall Islands?
Ensure brevity in your answer.  -7.82. In the year 2012, what is the difference between the Value added (% of GDP) of High income: nonOECD and Value added (% of GDP) of Thailand?
Provide a short and direct response. 7.73. In the year 2012, what is the difference between the Value added (% of GDP) in Jordan and Value added (% of GDP) in Marshall Islands?
Make the answer very short. 0.29. In the year 2012, what is the difference between the Value added (% of GDP) in Jordan and Value added (% of GDP) in Thailand?
Make the answer very short. 15.84. In the year 2012, what is the difference between the Value added (% of GDP) in Marshall Islands and Value added (% of GDP) in Thailand?
Offer a very short reply. 15.55. In the year 2013, what is the difference between the Value added (% of GDP) in High income: nonOECD and Value added (% of GDP) in Jordan?
Offer a very short reply. -7.84. In the year 2013, what is the difference between the Value added (% of GDP) in High income: nonOECD and Value added (% of GDP) in Marshall Islands?
Give a very brief answer. -8.52. In the year 2013, what is the difference between the Value added (% of GDP) in High income: nonOECD and Value added (% of GDP) in Thailand?
Ensure brevity in your answer.  7.34. In the year 2013, what is the difference between the Value added (% of GDP) in Jordan and Value added (% of GDP) in Marshall Islands?
Give a very brief answer. -0.68. In the year 2013, what is the difference between the Value added (% of GDP) of Jordan and Value added (% of GDP) of Thailand?
Provide a succinct answer. 15.18. In the year 2013, what is the difference between the Value added (% of GDP) in Marshall Islands and Value added (% of GDP) in Thailand?
Provide a short and direct response. 15.86. What is the ratio of the Value added (% of GDP) of High income: nonOECD in 2006 to that in 2007?
Your response must be concise. 0.98. What is the ratio of the Value added (% of GDP) in Jordan in 2006 to that in 2007?
Your answer should be compact. 1.04. What is the ratio of the Value added (% of GDP) of Marshall Islands in 2006 to that in 2007?
Give a very brief answer. 1.02. What is the ratio of the Value added (% of GDP) of Thailand in 2006 to that in 2007?
Offer a very short reply. 1. What is the ratio of the Value added (% of GDP) in High income: nonOECD in 2006 to that in 2008?
Your answer should be very brief. 0.97. What is the ratio of the Value added (% of GDP) in Jordan in 2006 to that in 2008?
Your answer should be compact. 1.07. What is the ratio of the Value added (% of GDP) of Marshall Islands in 2006 to that in 2008?
Your answer should be very brief. 1.04. What is the ratio of the Value added (% of GDP) in Thailand in 2006 to that in 2008?
Your response must be concise. 1.02. What is the ratio of the Value added (% of GDP) in High income: nonOECD in 2006 to that in 2009?
Keep it short and to the point. 0.92. What is the ratio of the Value added (% of GDP) of Jordan in 2006 to that in 2009?
Keep it short and to the point. 1.05. What is the ratio of the Value added (% of GDP) in Marshall Islands in 2006 to that in 2009?
Ensure brevity in your answer.  1.05. What is the ratio of the Value added (% of GDP) of Thailand in 2006 to that in 2009?
Provide a succinct answer. 1. What is the ratio of the Value added (% of GDP) in High income: nonOECD in 2006 to that in 2010?
Keep it short and to the point. 0.96. What is the ratio of the Value added (% of GDP) of Jordan in 2006 to that in 2010?
Offer a terse response. 1.03. What is the ratio of the Value added (% of GDP) in Marshall Islands in 2006 to that in 2010?
Make the answer very short. 1.09. What is the ratio of the Value added (% of GDP) in Thailand in 2006 to that in 2010?
Ensure brevity in your answer.  1.04. What is the ratio of the Value added (% of GDP) in High income: nonOECD in 2006 to that in 2011?
Make the answer very short. 0.97. What is the ratio of the Value added (% of GDP) in Jordan in 2006 to that in 2011?
Give a very brief answer. 1.04. What is the ratio of the Value added (% of GDP) of Marshall Islands in 2006 to that in 2011?
Offer a very short reply. 1.11. What is the ratio of the Value added (% of GDP) of Thailand in 2006 to that in 2011?
Make the answer very short. 1.02. What is the ratio of the Value added (% of GDP) of High income: nonOECD in 2006 to that in 2012?
Provide a short and direct response. 0.96. What is the ratio of the Value added (% of GDP) of Marshall Islands in 2006 to that in 2012?
Make the answer very short. 1.18. What is the ratio of the Value added (% of GDP) of High income: nonOECD in 2006 to that in 2013?
Offer a terse response. 0.95. What is the ratio of the Value added (% of GDP) in Jordan in 2006 to that in 2013?
Make the answer very short. 1.02. What is the ratio of the Value added (% of GDP) in Marshall Islands in 2006 to that in 2013?
Provide a succinct answer. 1.16. What is the ratio of the Value added (% of GDP) of Thailand in 2006 to that in 2013?
Provide a short and direct response. 0.99. What is the ratio of the Value added (% of GDP) in High income: nonOECD in 2007 to that in 2008?
Give a very brief answer. 0.98. What is the ratio of the Value added (% of GDP) of Jordan in 2007 to that in 2008?
Ensure brevity in your answer.  1.03. What is the ratio of the Value added (% of GDP) of Marshall Islands in 2007 to that in 2008?
Provide a short and direct response. 1.02. What is the ratio of the Value added (% of GDP) in Thailand in 2007 to that in 2008?
Your answer should be compact. 1.02. What is the ratio of the Value added (% of GDP) in High income: nonOECD in 2007 to that in 2009?
Make the answer very short. 0.93. What is the ratio of the Value added (% of GDP) of Jordan in 2007 to that in 2009?
Keep it short and to the point. 1.01. What is the ratio of the Value added (% of GDP) of Marshall Islands in 2007 to that in 2009?
Your answer should be compact. 1.03. What is the ratio of the Value added (% of GDP) of High income: nonOECD in 2007 to that in 2010?
Your response must be concise. 0.97. What is the ratio of the Value added (% of GDP) in Jordan in 2007 to that in 2010?
Make the answer very short. 1. What is the ratio of the Value added (% of GDP) of Marshall Islands in 2007 to that in 2010?
Your answer should be compact. 1.06. What is the ratio of the Value added (% of GDP) of Thailand in 2007 to that in 2010?
Your response must be concise. 1.03. What is the ratio of the Value added (% of GDP) in High income: nonOECD in 2007 to that in 2011?
Your answer should be compact. 0.98. What is the ratio of the Value added (% of GDP) of Marshall Islands in 2007 to that in 2011?
Ensure brevity in your answer.  1.09. What is the ratio of the Value added (% of GDP) of Thailand in 2007 to that in 2011?
Offer a terse response. 1.02. What is the ratio of the Value added (% of GDP) in High income: nonOECD in 2007 to that in 2012?
Keep it short and to the point. 0.97. What is the ratio of the Value added (% of GDP) of Jordan in 2007 to that in 2012?
Ensure brevity in your answer.  0.98. What is the ratio of the Value added (% of GDP) in Marshall Islands in 2007 to that in 2012?
Offer a terse response. 1.16. What is the ratio of the Value added (% of GDP) of Thailand in 2007 to that in 2012?
Give a very brief answer. 1. What is the ratio of the Value added (% of GDP) in High income: nonOECD in 2007 to that in 2013?
Offer a terse response. 0.97. What is the ratio of the Value added (% of GDP) of Jordan in 2007 to that in 2013?
Your response must be concise. 0.98. What is the ratio of the Value added (% of GDP) in Marshall Islands in 2007 to that in 2013?
Offer a terse response. 1.14. What is the ratio of the Value added (% of GDP) of High income: nonOECD in 2008 to that in 2009?
Provide a succinct answer. 0.95. What is the ratio of the Value added (% of GDP) of Jordan in 2008 to that in 2009?
Provide a short and direct response. 0.98. What is the ratio of the Value added (% of GDP) in Marshall Islands in 2008 to that in 2009?
Provide a short and direct response. 1.01. What is the ratio of the Value added (% of GDP) in Thailand in 2008 to that in 2009?
Ensure brevity in your answer.  0.98. What is the ratio of the Value added (% of GDP) of Jordan in 2008 to that in 2010?
Give a very brief answer. 0.96. What is the ratio of the Value added (% of GDP) of Marshall Islands in 2008 to that in 2010?
Keep it short and to the point. 1.04. What is the ratio of the Value added (% of GDP) of Thailand in 2008 to that in 2010?
Ensure brevity in your answer.  1.02. What is the ratio of the Value added (% of GDP) of High income: nonOECD in 2008 to that in 2011?
Provide a short and direct response. 1. What is the ratio of the Value added (% of GDP) of Jordan in 2008 to that in 2011?
Ensure brevity in your answer.  0.97. What is the ratio of the Value added (% of GDP) in Marshall Islands in 2008 to that in 2011?
Offer a very short reply. 1.07. What is the ratio of the Value added (% of GDP) in Thailand in 2008 to that in 2011?
Ensure brevity in your answer.  1. What is the ratio of the Value added (% of GDP) in High income: nonOECD in 2008 to that in 2012?
Provide a short and direct response. 0.99. What is the ratio of the Value added (% of GDP) of Jordan in 2008 to that in 2012?
Your answer should be compact. 0.95. What is the ratio of the Value added (% of GDP) in Marshall Islands in 2008 to that in 2012?
Ensure brevity in your answer.  1.13. What is the ratio of the Value added (% of GDP) of Thailand in 2008 to that in 2012?
Keep it short and to the point. 0.99. What is the ratio of the Value added (% of GDP) of High income: nonOECD in 2008 to that in 2013?
Provide a short and direct response. 0.98. What is the ratio of the Value added (% of GDP) in Jordan in 2008 to that in 2013?
Your response must be concise. 0.95. What is the ratio of the Value added (% of GDP) in Marshall Islands in 2008 to that in 2013?
Provide a succinct answer. 1.12. What is the ratio of the Value added (% of GDP) of Thailand in 2008 to that in 2013?
Offer a terse response. 0.97. What is the ratio of the Value added (% of GDP) of High income: nonOECD in 2009 to that in 2010?
Ensure brevity in your answer.  1.04. What is the ratio of the Value added (% of GDP) in Jordan in 2009 to that in 2010?
Make the answer very short. 0.98. What is the ratio of the Value added (% of GDP) in Marshall Islands in 2009 to that in 2010?
Your answer should be compact. 1.04. What is the ratio of the Value added (% of GDP) in Thailand in 2009 to that in 2010?
Provide a short and direct response. 1.04. What is the ratio of the Value added (% of GDP) in High income: nonOECD in 2009 to that in 2011?
Provide a short and direct response. 1.05. What is the ratio of the Value added (% of GDP) in Jordan in 2009 to that in 2011?
Give a very brief answer. 0.99. What is the ratio of the Value added (% of GDP) of Marshall Islands in 2009 to that in 2011?
Give a very brief answer. 1.06. What is the ratio of the Value added (% of GDP) of Thailand in 2009 to that in 2011?
Give a very brief answer. 1.02. What is the ratio of the Value added (% of GDP) of High income: nonOECD in 2009 to that in 2012?
Give a very brief answer. 1.04. What is the ratio of the Value added (% of GDP) in Jordan in 2009 to that in 2012?
Make the answer very short. 0.97. What is the ratio of the Value added (% of GDP) of Marshall Islands in 2009 to that in 2012?
Make the answer very short. 1.13. What is the ratio of the Value added (% of GDP) of High income: nonOECD in 2009 to that in 2013?
Make the answer very short. 1.03. What is the ratio of the Value added (% of GDP) in Jordan in 2009 to that in 2013?
Your answer should be very brief. 0.97. What is the ratio of the Value added (% of GDP) in Marshall Islands in 2009 to that in 2013?
Your answer should be very brief. 1.11. What is the ratio of the Value added (% of GDP) in High income: nonOECD in 2010 to that in 2011?
Offer a very short reply. 1.01. What is the ratio of the Value added (% of GDP) of Jordan in 2010 to that in 2011?
Provide a short and direct response. 1. What is the ratio of the Value added (% of GDP) of Marshall Islands in 2010 to that in 2011?
Your response must be concise. 1.02. What is the ratio of the Value added (% of GDP) in Thailand in 2010 to that in 2011?
Keep it short and to the point. 0.98. What is the ratio of the Value added (% of GDP) of Jordan in 2010 to that in 2012?
Give a very brief answer. 0.99. What is the ratio of the Value added (% of GDP) in Marshall Islands in 2010 to that in 2012?
Offer a very short reply. 1.09. What is the ratio of the Value added (% of GDP) in Thailand in 2010 to that in 2012?
Your response must be concise. 0.97. What is the ratio of the Value added (% of GDP) in High income: nonOECD in 2010 to that in 2013?
Keep it short and to the point. 0.99. What is the ratio of the Value added (% of GDP) of Jordan in 2010 to that in 2013?
Your answer should be very brief. 0.98. What is the ratio of the Value added (% of GDP) of Marshall Islands in 2010 to that in 2013?
Provide a short and direct response. 1.07. What is the ratio of the Value added (% of GDP) in Thailand in 2010 to that in 2013?
Make the answer very short. 0.96. What is the ratio of the Value added (% of GDP) of High income: nonOECD in 2011 to that in 2012?
Give a very brief answer. 0.99. What is the ratio of the Value added (% of GDP) of Jordan in 2011 to that in 2012?
Your response must be concise. 0.98. What is the ratio of the Value added (% of GDP) in Marshall Islands in 2011 to that in 2012?
Give a very brief answer. 1.06. What is the ratio of the Value added (% of GDP) in Thailand in 2011 to that in 2012?
Offer a terse response. 0.99. What is the ratio of the Value added (% of GDP) of High income: nonOECD in 2011 to that in 2013?
Ensure brevity in your answer.  0.98. What is the ratio of the Value added (% of GDP) in Jordan in 2011 to that in 2013?
Your answer should be very brief. 0.98. What is the ratio of the Value added (% of GDP) of Marshall Islands in 2011 to that in 2013?
Offer a very short reply. 1.05. What is the ratio of the Value added (% of GDP) of Thailand in 2011 to that in 2013?
Ensure brevity in your answer.  0.97. What is the ratio of the Value added (% of GDP) in Jordan in 2012 to that in 2013?
Provide a short and direct response. 1. What is the ratio of the Value added (% of GDP) in Marshall Islands in 2012 to that in 2013?
Offer a terse response. 0.98. What is the ratio of the Value added (% of GDP) of Thailand in 2012 to that in 2013?
Make the answer very short. 0.99. What is the difference between the highest and the second highest Value added (% of GDP) in High income: nonOECD?
Your answer should be compact. 2.02. What is the difference between the highest and the second highest Value added (% of GDP) of Jordan?
Ensure brevity in your answer.  1.17. What is the difference between the highest and the second highest Value added (% of GDP) of Marshall Islands?
Make the answer very short. 1.61. What is the difference between the highest and the second highest Value added (% of GDP) of Thailand?
Make the answer very short. 0.24. What is the difference between the highest and the lowest Value added (% of GDP) of High income: nonOECD?
Provide a succinct answer. 4.97. What is the difference between the highest and the lowest Value added (% of GDP) in Jordan?
Your answer should be very brief. 4.61. What is the difference between the highest and the lowest Value added (% of GDP) in Marshall Islands?
Offer a very short reply. 12.02. What is the difference between the highest and the lowest Value added (% of GDP) in Thailand?
Keep it short and to the point. 2.29. 